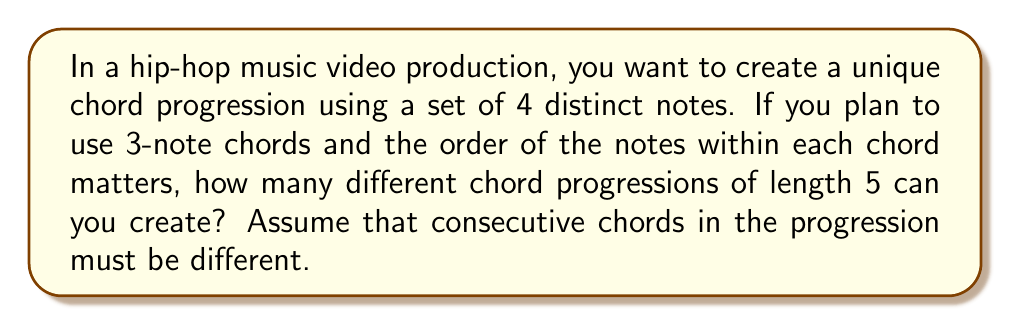Solve this math problem. Let's approach this step-by-step using concepts from group theory:

1) First, we need to calculate the number of possible 3-note chords from 4 distinct notes. This is a permutation:

   $P(4,3) = \frac{4!}{(4-3)!} = \frac{4!}{1!} = 24$

2) Now, we're creating a progression of length 5, where each chord is chosen from these 24 possibilities. However, consecutive chords must be different.

3) This scenario can be modeled as a directed graph, where each vertex represents a chord, and edges represent valid transitions between chords.

4) For the first chord, we have 24 choices.

5) For each subsequent chord, we have 23 choices (all chords except the one just used).

6) This forms a sequence of choices: 24 * 23 * 23 * 23 * 23

7) Therefore, the total number of possible progressions is:

   $24 \cdot 23^4$

8) Calculating this:
   
   $24 \cdot 23^4 = 24 \cdot 279841 = 6,716,184$

This approach uses the concept of symmetry groups in music theory, where the set of all possible chord progressions forms a group under the operation of concatenation, subject to our constraint of no consecutive repetitions.
Answer: $6,716,184$ 